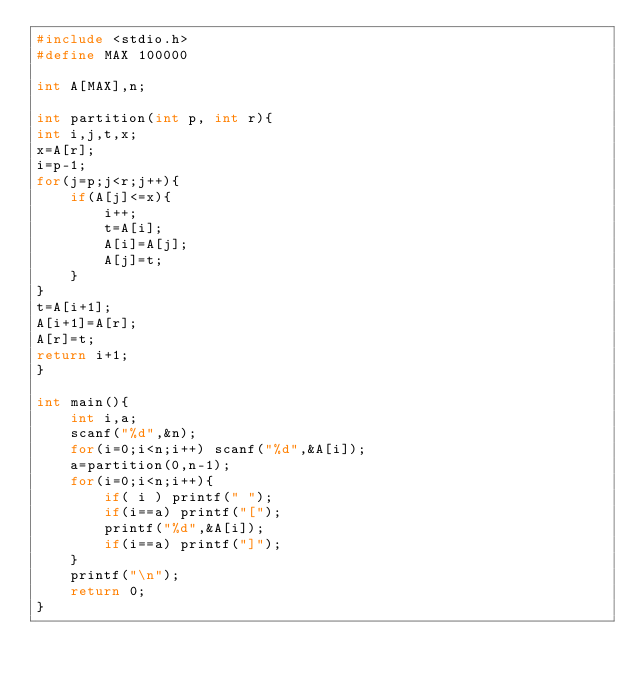<code> <loc_0><loc_0><loc_500><loc_500><_C_>#include <stdio.h>
#define MAX 100000

int A[MAX],n;

int partition(int p, int r){
int i,j,t,x;
x=A[r];
i=p-1;
for(j=p;j<r;j++){
    if(A[j]<=x){
        i++;
        t=A[i];
        A[i]=A[j];
        A[j]=t;
    }
}
t=A[i+1];
A[i+1]=A[r];
A[r]=t;
return i+1;
}

int main(){
    int i,a;
    scanf("%d",&n);
    for(i=0;i<n;i++) scanf("%d",&A[i]);
    a=partition(0,n-1);
    for(i=0;i<n;i++){
        if( i ) printf(" ");
        if(i==a) printf("[");
        printf("%d",&A[i]);
        if(i==a) printf("]");
    }
    printf("\n");
    return 0;
}
</code> 